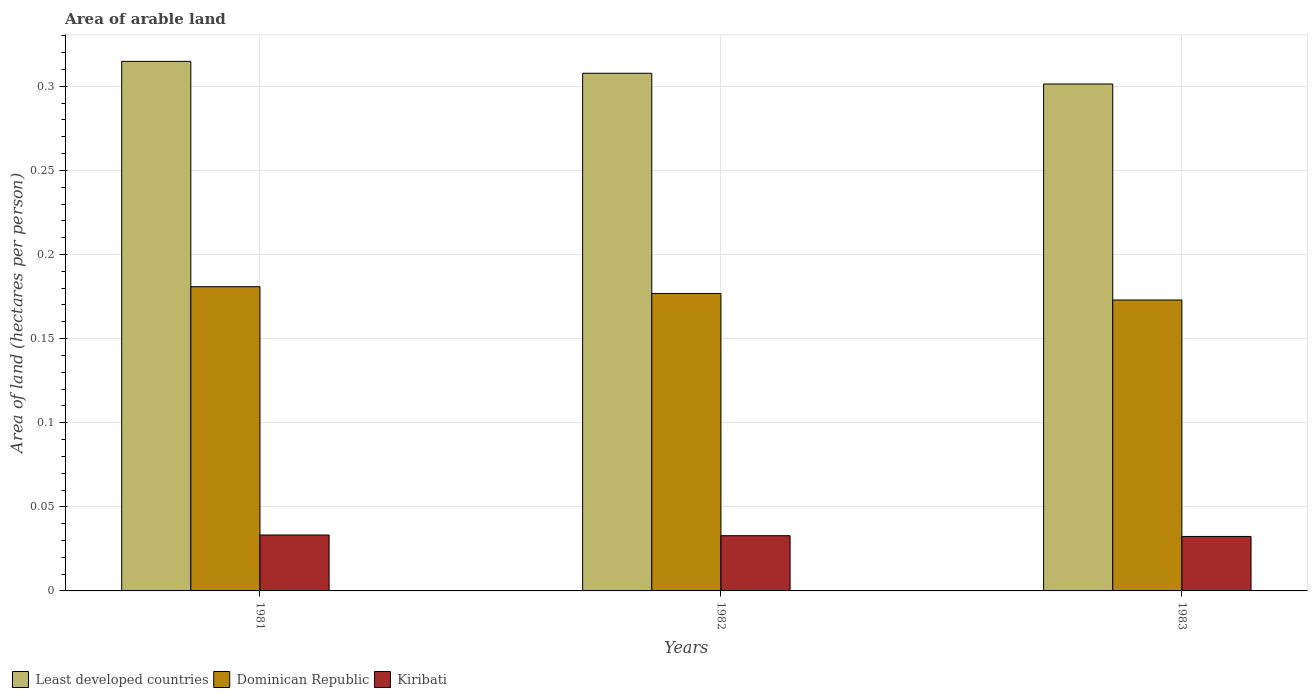Are the number of bars per tick equal to the number of legend labels?
Provide a succinct answer. Yes. Are the number of bars on each tick of the X-axis equal?
Provide a short and direct response. Yes. How many bars are there on the 3rd tick from the left?
Your answer should be compact. 3. What is the label of the 3rd group of bars from the left?
Provide a succinct answer. 1983. In how many cases, is the number of bars for a given year not equal to the number of legend labels?
Provide a succinct answer. 0. What is the total arable land in Dominican Republic in 1982?
Keep it short and to the point. 0.18. Across all years, what is the maximum total arable land in Dominican Republic?
Offer a terse response. 0.18. Across all years, what is the minimum total arable land in Kiribati?
Provide a succinct answer. 0.03. In which year was the total arable land in Dominican Republic minimum?
Keep it short and to the point. 1983. What is the total total arable land in Least developed countries in the graph?
Offer a very short reply. 0.92. What is the difference between the total arable land in Least developed countries in 1982 and that in 1983?
Your answer should be very brief. 0.01. What is the difference between the total arable land in Dominican Republic in 1982 and the total arable land in Kiribati in 1983?
Provide a short and direct response. 0.14. What is the average total arable land in Dominican Republic per year?
Your answer should be compact. 0.18. In the year 1983, what is the difference between the total arable land in Dominican Republic and total arable land in Least developed countries?
Offer a very short reply. -0.13. In how many years, is the total arable land in Dominican Republic greater than 0.28 hectares per person?
Your answer should be compact. 0. What is the ratio of the total arable land in Dominican Republic in 1982 to that in 1983?
Make the answer very short. 1.02. What is the difference between the highest and the second highest total arable land in Dominican Republic?
Your answer should be compact. 0. What is the difference between the highest and the lowest total arable land in Kiribati?
Your answer should be very brief. 0. What does the 1st bar from the left in 1983 represents?
Your answer should be very brief. Least developed countries. What does the 2nd bar from the right in 1981 represents?
Your response must be concise. Dominican Republic. How many years are there in the graph?
Your answer should be very brief. 3. What is the difference between two consecutive major ticks on the Y-axis?
Provide a succinct answer. 0.05. Are the values on the major ticks of Y-axis written in scientific E-notation?
Your answer should be compact. No. Does the graph contain grids?
Offer a terse response. Yes. How many legend labels are there?
Provide a succinct answer. 3. What is the title of the graph?
Offer a very short reply. Area of arable land. Does "Guam" appear as one of the legend labels in the graph?
Provide a succinct answer. No. What is the label or title of the X-axis?
Keep it short and to the point. Years. What is the label or title of the Y-axis?
Provide a short and direct response. Area of land (hectares per person). What is the Area of land (hectares per person) of Least developed countries in 1981?
Offer a terse response. 0.31. What is the Area of land (hectares per person) of Dominican Republic in 1981?
Your answer should be very brief. 0.18. What is the Area of land (hectares per person) in Kiribati in 1981?
Keep it short and to the point. 0.03. What is the Area of land (hectares per person) of Least developed countries in 1982?
Provide a succinct answer. 0.31. What is the Area of land (hectares per person) in Dominican Republic in 1982?
Your response must be concise. 0.18. What is the Area of land (hectares per person) of Kiribati in 1982?
Ensure brevity in your answer.  0.03. What is the Area of land (hectares per person) of Least developed countries in 1983?
Your answer should be compact. 0.3. What is the Area of land (hectares per person) in Dominican Republic in 1983?
Provide a short and direct response. 0.17. What is the Area of land (hectares per person) of Kiribati in 1983?
Provide a short and direct response. 0.03. Across all years, what is the maximum Area of land (hectares per person) in Least developed countries?
Keep it short and to the point. 0.31. Across all years, what is the maximum Area of land (hectares per person) of Dominican Republic?
Ensure brevity in your answer.  0.18. Across all years, what is the maximum Area of land (hectares per person) of Kiribati?
Your answer should be very brief. 0.03. Across all years, what is the minimum Area of land (hectares per person) in Least developed countries?
Provide a succinct answer. 0.3. Across all years, what is the minimum Area of land (hectares per person) in Dominican Republic?
Offer a terse response. 0.17. Across all years, what is the minimum Area of land (hectares per person) in Kiribati?
Offer a very short reply. 0.03. What is the total Area of land (hectares per person) in Least developed countries in the graph?
Keep it short and to the point. 0.92. What is the total Area of land (hectares per person) in Dominican Republic in the graph?
Provide a succinct answer. 0.53. What is the total Area of land (hectares per person) in Kiribati in the graph?
Your answer should be compact. 0.1. What is the difference between the Area of land (hectares per person) of Least developed countries in 1981 and that in 1982?
Provide a short and direct response. 0.01. What is the difference between the Area of land (hectares per person) in Dominican Republic in 1981 and that in 1982?
Your answer should be compact. 0. What is the difference between the Area of land (hectares per person) in Kiribati in 1981 and that in 1982?
Offer a terse response. 0. What is the difference between the Area of land (hectares per person) in Least developed countries in 1981 and that in 1983?
Your response must be concise. 0.01. What is the difference between the Area of land (hectares per person) of Dominican Republic in 1981 and that in 1983?
Ensure brevity in your answer.  0.01. What is the difference between the Area of land (hectares per person) in Kiribati in 1981 and that in 1983?
Offer a very short reply. 0. What is the difference between the Area of land (hectares per person) in Least developed countries in 1982 and that in 1983?
Make the answer very short. 0.01. What is the difference between the Area of land (hectares per person) of Dominican Republic in 1982 and that in 1983?
Offer a terse response. 0. What is the difference between the Area of land (hectares per person) in Kiribati in 1982 and that in 1983?
Offer a terse response. 0. What is the difference between the Area of land (hectares per person) in Least developed countries in 1981 and the Area of land (hectares per person) in Dominican Republic in 1982?
Your answer should be compact. 0.14. What is the difference between the Area of land (hectares per person) in Least developed countries in 1981 and the Area of land (hectares per person) in Kiribati in 1982?
Offer a very short reply. 0.28. What is the difference between the Area of land (hectares per person) in Dominican Republic in 1981 and the Area of land (hectares per person) in Kiribati in 1982?
Offer a terse response. 0.15. What is the difference between the Area of land (hectares per person) in Least developed countries in 1981 and the Area of land (hectares per person) in Dominican Republic in 1983?
Provide a short and direct response. 0.14. What is the difference between the Area of land (hectares per person) in Least developed countries in 1981 and the Area of land (hectares per person) in Kiribati in 1983?
Your response must be concise. 0.28. What is the difference between the Area of land (hectares per person) in Dominican Republic in 1981 and the Area of land (hectares per person) in Kiribati in 1983?
Your response must be concise. 0.15. What is the difference between the Area of land (hectares per person) in Least developed countries in 1982 and the Area of land (hectares per person) in Dominican Republic in 1983?
Offer a very short reply. 0.13. What is the difference between the Area of land (hectares per person) in Least developed countries in 1982 and the Area of land (hectares per person) in Kiribati in 1983?
Your answer should be compact. 0.28. What is the difference between the Area of land (hectares per person) in Dominican Republic in 1982 and the Area of land (hectares per person) in Kiribati in 1983?
Make the answer very short. 0.14. What is the average Area of land (hectares per person) of Least developed countries per year?
Provide a short and direct response. 0.31. What is the average Area of land (hectares per person) in Dominican Republic per year?
Your answer should be compact. 0.18. What is the average Area of land (hectares per person) in Kiribati per year?
Your answer should be very brief. 0.03. In the year 1981, what is the difference between the Area of land (hectares per person) of Least developed countries and Area of land (hectares per person) of Dominican Republic?
Ensure brevity in your answer.  0.13. In the year 1981, what is the difference between the Area of land (hectares per person) in Least developed countries and Area of land (hectares per person) in Kiribati?
Provide a short and direct response. 0.28. In the year 1981, what is the difference between the Area of land (hectares per person) of Dominican Republic and Area of land (hectares per person) of Kiribati?
Your answer should be very brief. 0.15. In the year 1982, what is the difference between the Area of land (hectares per person) in Least developed countries and Area of land (hectares per person) in Dominican Republic?
Offer a terse response. 0.13. In the year 1982, what is the difference between the Area of land (hectares per person) in Least developed countries and Area of land (hectares per person) in Kiribati?
Give a very brief answer. 0.27. In the year 1982, what is the difference between the Area of land (hectares per person) of Dominican Republic and Area of land (hectares per person) of Kiribati?
Ensure brevity in your answer.  0.14. In the year 1983, what is the difference between the Area of land (hectares per person) of Least developed countries and Area of land (hectares per person) of Dominican Republic?
Make the answer very short. 0.13. In the year 1983, what is the difference between the Area of land (hectares per person) in Least developed countries and Area of land (hectares per person) in Kiribati?
Your answer should be compact. 0.27. In the year 1983, what is the difference between the Area of land (hectares per person) of Dominican Republic and Area of land (hectares per person) of Kiribati?
Provide a succinct answer. 0.14. What is the ratio of the Area of land (hectares per person) of Dominican Republic in 1981 to that in 1982?
Your answer should be very brief. 1.02. What is the ratio of the Area of land (hectares per person) of Least developed countries in 1981 to that in 1983?
Keep it short and to the point. 1.04. What is the ratio of the Area of land (hectares per person) in Dominican Republic in 1981 to that in 1983?
Provide a succinct answer. 1.05. What is the ratio of the Area of land (hectares per person) of Least developed countries in 1982 to that in 1983?
Your response must be concise. 1.02. What is the ratio of the Area of land (hectares per person) in Dominican Republic in 1982 to that in 1983?
Offer a terse response. 1.02. What is the ratio of the Area of land (hectares per person) in Kiribati in 1982 to that in 1983?
Provide a short and direct response. 1.01. What is the difference between the highest and the second highest Area of land (hectares per person) of Least developed countries?
Give a very brief answer. 0.01. What is the difference between the highest and the second highest Area of land (hectares per person) in Dominican Republic?
Give a very brief answer. 0. What is the difference between the highest and the lowest Area of land (hectares per person) of Least developed countries?
Offer a terse response. 0.01. What is the difference between the highest and the lowest Area of land (hectares per person) of Dominican Republic?
Provide a succinct answer. 0.01. What is the difference between the highest and the lowest Area of land (hectares per person) in Kiribati?
Your answer should be very brief. 0. 